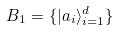<formula> <loc_0><loc_0><loc_500><loc_500>B _ { 1 } = \{ | a _ { i } \rangle _ { i = 1 } ^ { d } \}</formula> 